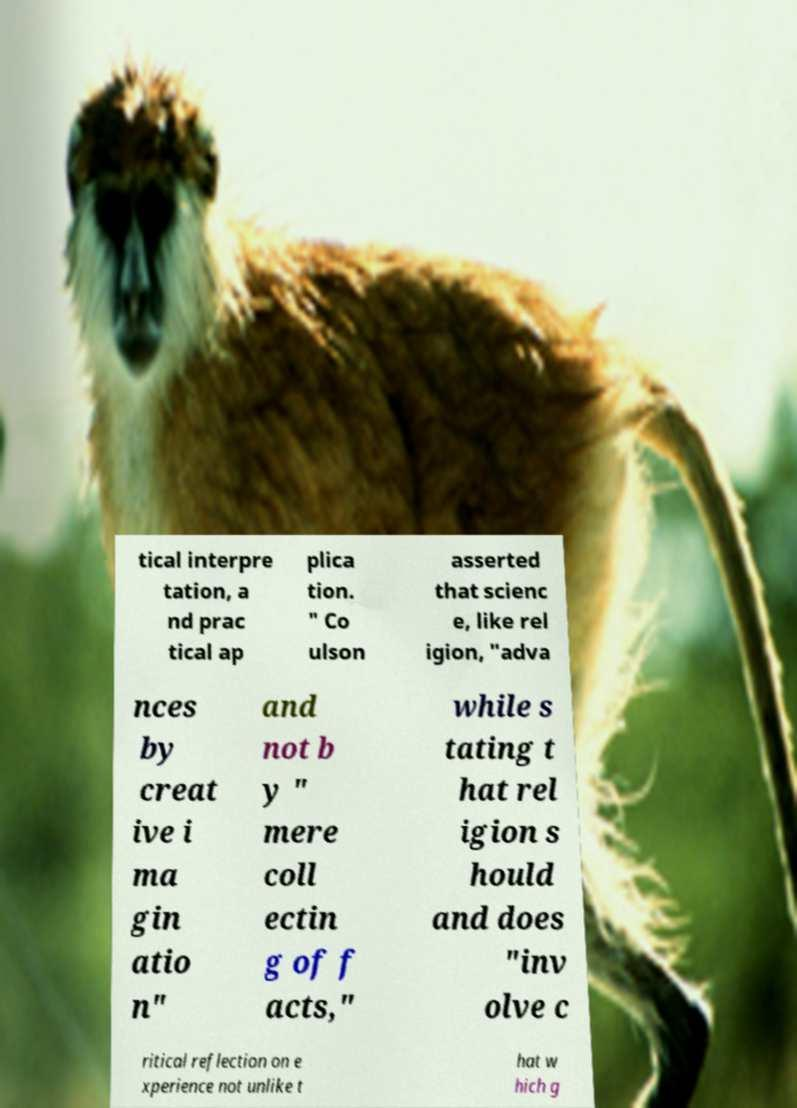Could you extract and type out the text from this image? tical interpre tation, a nd prac tical ap plica tion. " Co ulson asserted that scienc e, like rel igion, "adva nces by creat ive i ma gin atio n" and not b y " mere coll ectin g of f acts," while s tating t hat rel igion s hould and does "inv olve c ritical reflection on e xperience not unlike t hat w hich g 